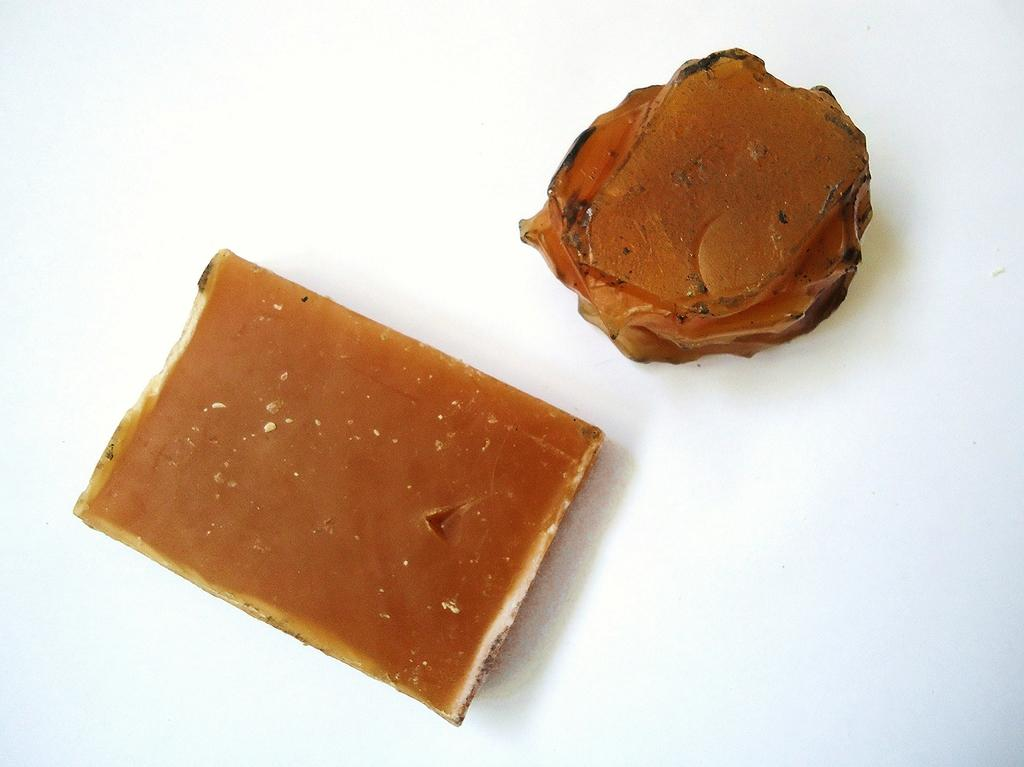What are the two brown color objects in the image? The objects look like jelly or wax. Where are these objects located in the image? The objects are kept on the floor. Can you see a kitten playing with the objects on the floor in the image? There is no kitten present in the image. Are there any cows or a lake visible in the image? There are no cows or a lake present in the image. 